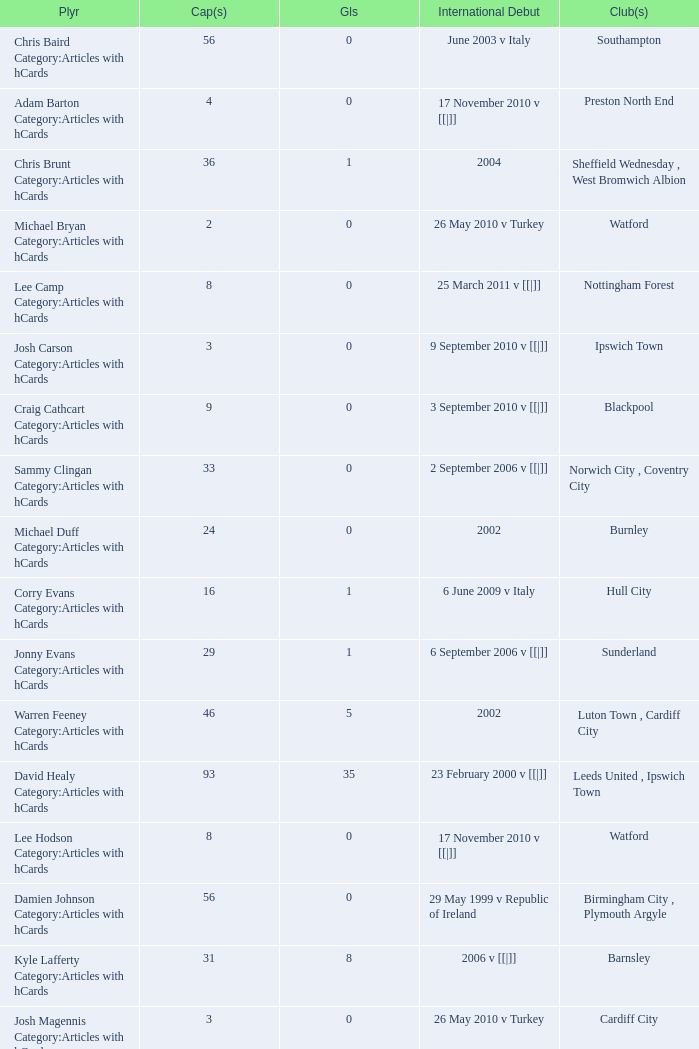How many players had 8 goals? 1.0. 